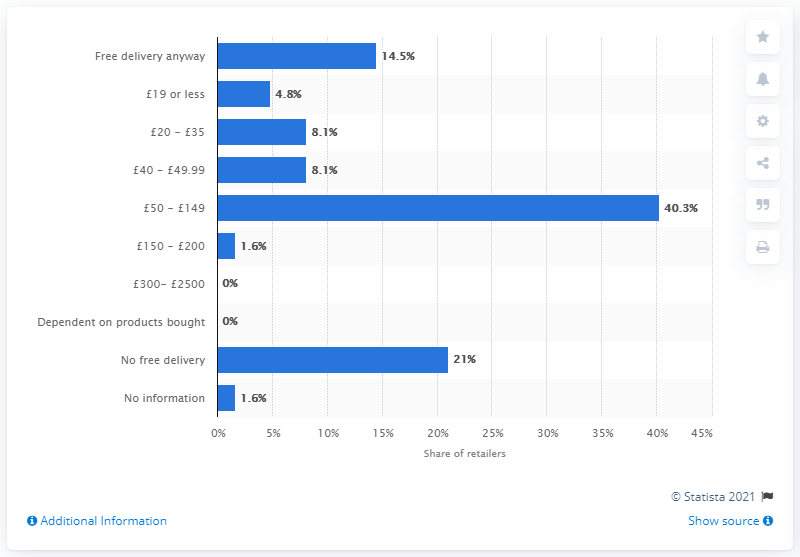Indicate a few pertinent items in this graphic. According to the data, 4.8% of leading retailers offered free delivery on orders under 19 pounds. 